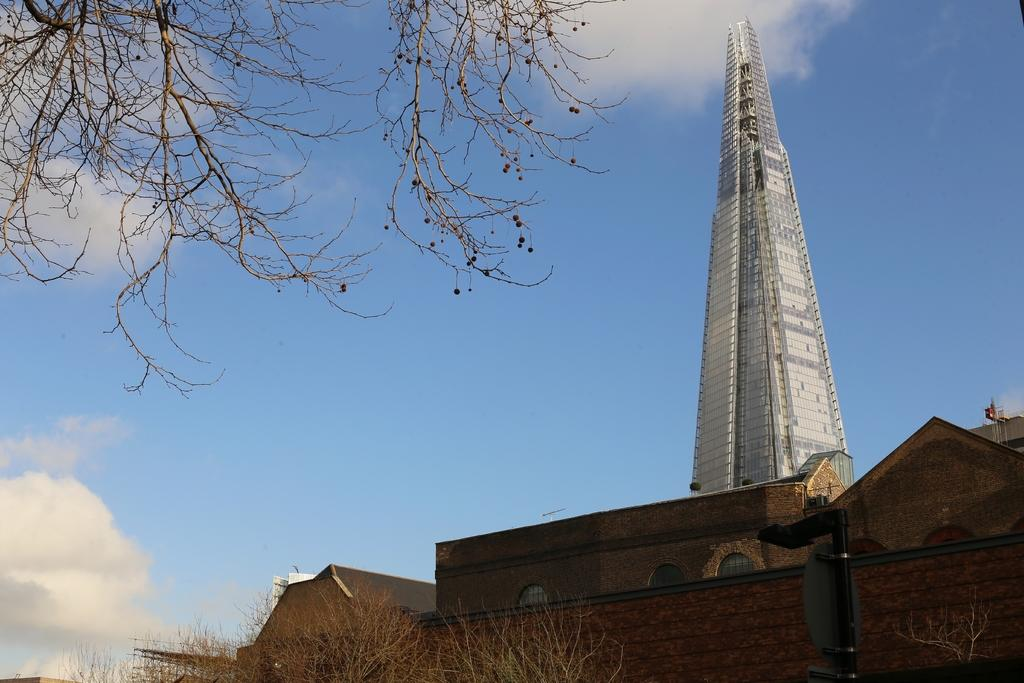What type of structures can be seen in the image? There are buildings and a tower in the image. What else can be seen in the image besides the structures? There are trees visible in the image. What type of guide is present in the image? There is no guide present in the image. What color is the silver in the image? There is no silver present in the image. 